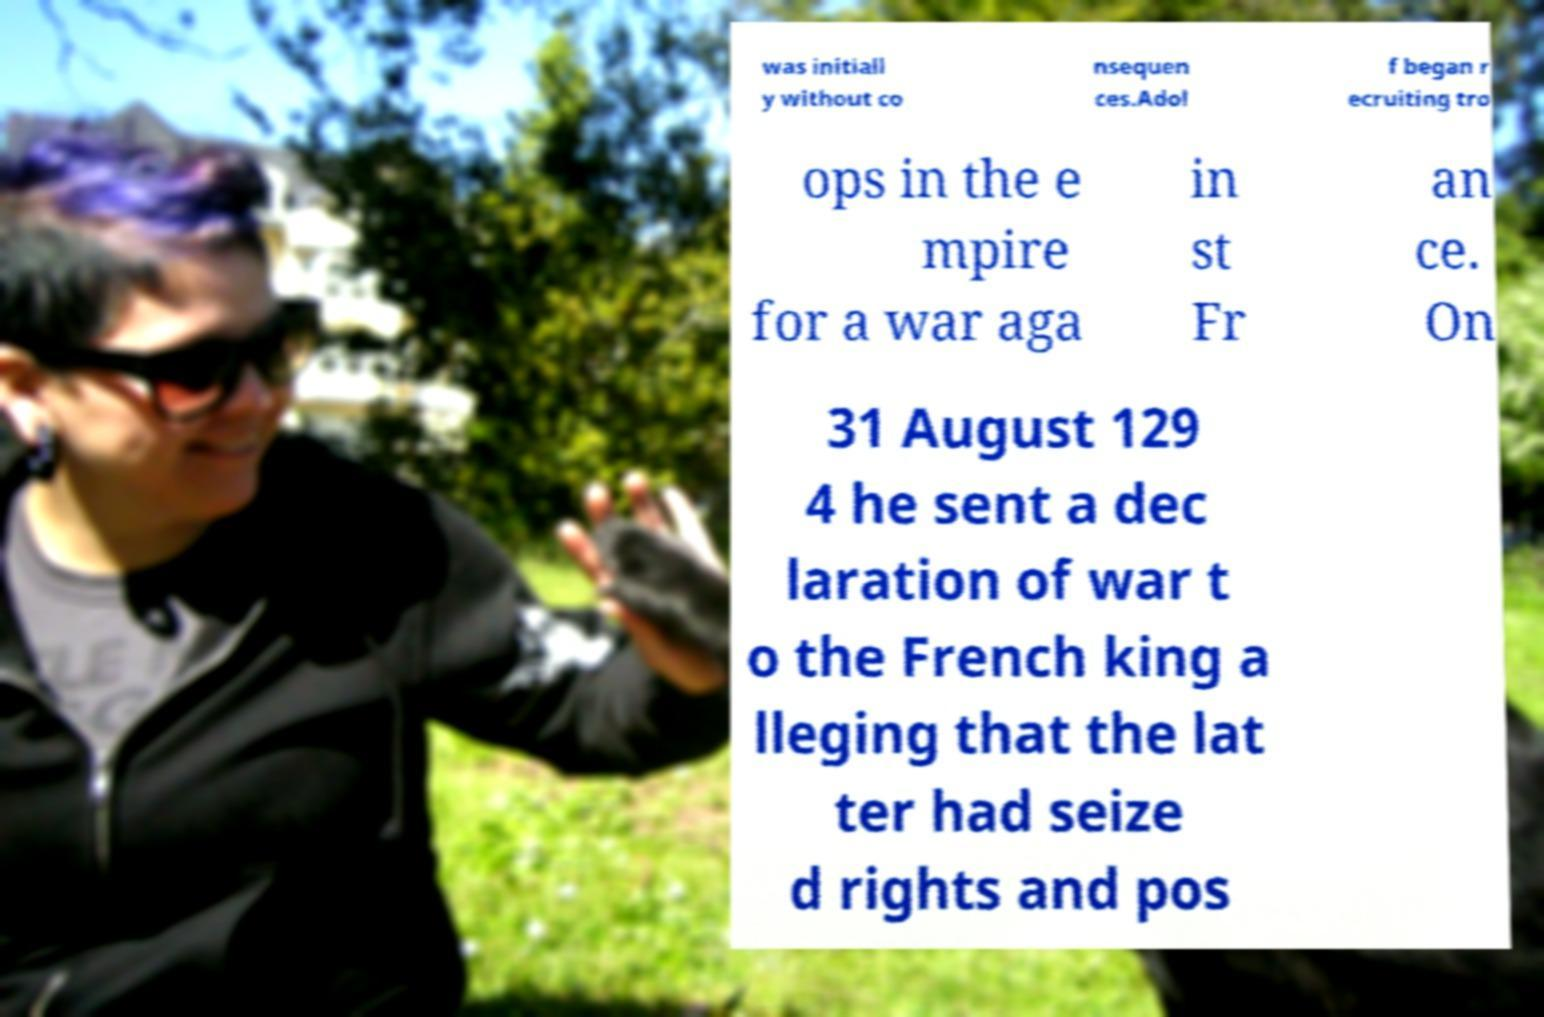For documentation purposes, I need the text within this image transcribed. Could you provide that? was initiall y without co nsequen ces.Adol f began r ecruiting tro ops in the e mpire for a war aga in st Fr an ce. On 31 August 129 4 he sent a dec laration of war t o the French king a lleging that the lat ter had seize d rights and pos 